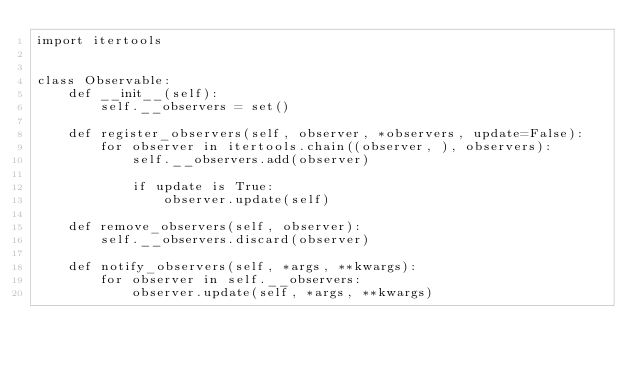Convert code to text. <code><loc_0><loc_0><loc_500><loc_500><_Python_>import itertools


class Observable:
    def __init__(self):
        self.__observers = set()

    def register_observers(self, observer, *observers, update=False):
        for observer in itertools.chain((observer, ), observers):
            self.__observers.add(observer)

            if update is True:
                observer.update(self)

    def remove_observers(self, observer):
        self.__observers.discard(observer)

    def notify_observers(self, *args, **kwargs):
        for observer in self.__observers:
            observer.update(self, *args, **kwargs)
</code> 